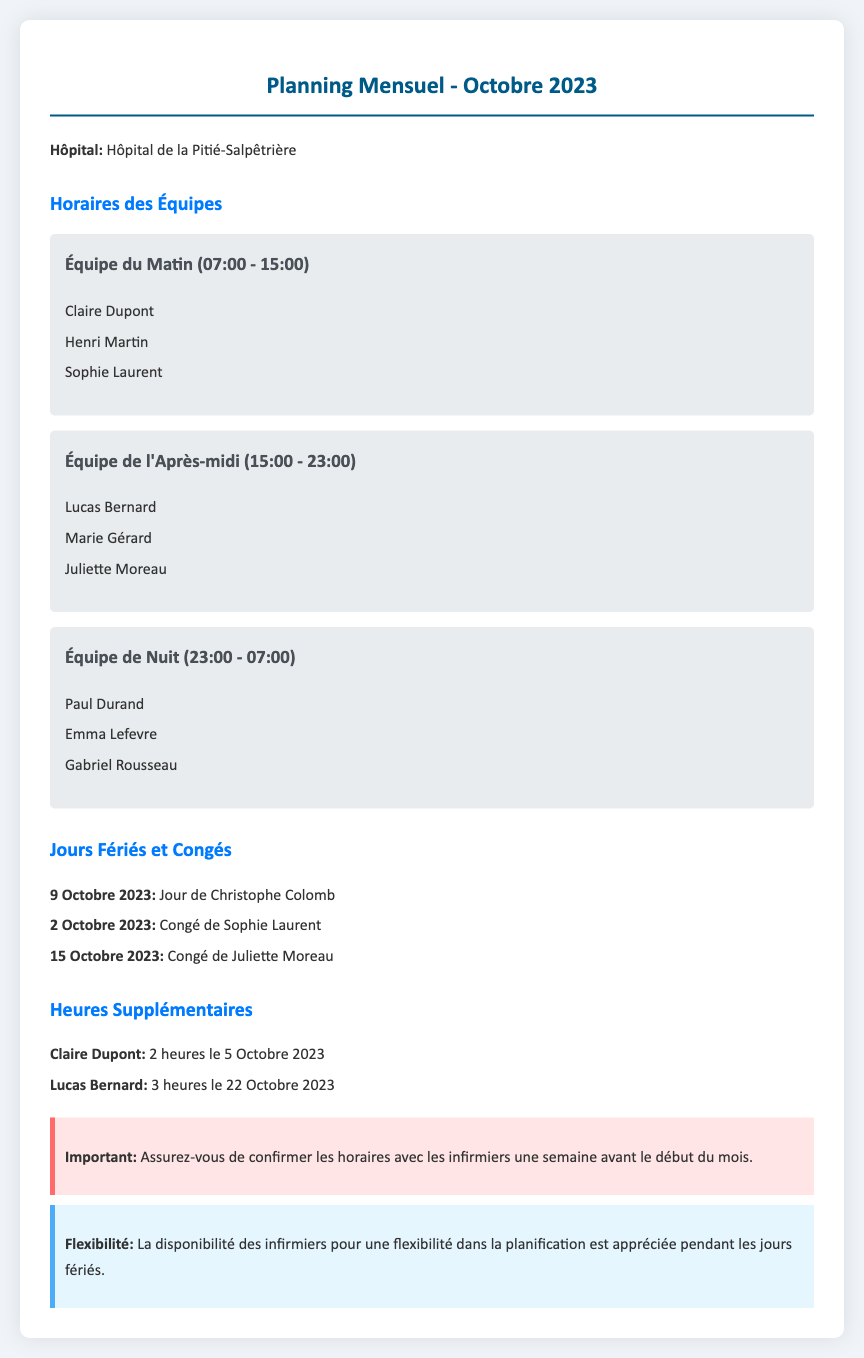Quelle est la date du jour de Christophe Colomb ? La date du jour de Christophe Colomb est précisée dans la section des jours fériés et sera le 9 octobre 2023.
Answer: 9 Octobre 2023 Qui fait partie de l'équipe du matin ? L'équipe du matin est énoncée dans la section des horaires des équipes, incluant Claire Dupont, Henri Martin, et Sophie Laurent.
Answer: Claire Dupont, Henri Martin, Sophie Laurent Combien d'heures supplémentaires a effectué Lucas Bernard ? Le montant des heures supplémentaires de Lucas Bernard est spécifié, qui est de 3 heures le 22 octobre 2023.
Answer: 3 heures Quel est le nom de l'infirmière en congé le 2 octobre ? Le nom de l'infirmière en congé le 2 octobre est mentionné dans la liste des congés, c'est Sophie Laurent.
Answer: Sophie Laurent Que doit-on confirmer une semaine avant le début du mois ? Il est indiqué dans la section importante qu'il faut confirmer les horaires avec les infirmiers une semaine avant le début du mois.
Answer: Les horaires Combien de membres composent l'équipe de nuit ? L'équipe de nuit est énumérée dans la section des horaires des équipes, et il est mentionné qu'elle est composée de trois membres.
Answer: 3 membres Quel est l'hôpital mentionné dans le document ? Le nom de l'hôpital est indiqué en haut du document, ce qui est l'Hôpital de la Pitié-Salpêtrière.
Answer: Hôpital de la Pitié-Salpêtrière Quel est le service d'Emma Lefevre ? Le service d'Emma Lefevre est précisé dans la section des horaires, où elle est membre de l'équipe de nuit.
Answer: Équipe de Nuit Quelle date les heures supplémentaires de Claire Dupont ont-elles eu lieu ? Les heures supplémentaires de Claire Dupont sont spécifiées pour le 5 octobre 2023, mentionnées dans la section des heures supplémentaires.
Answer: 5 Octobre 2023 